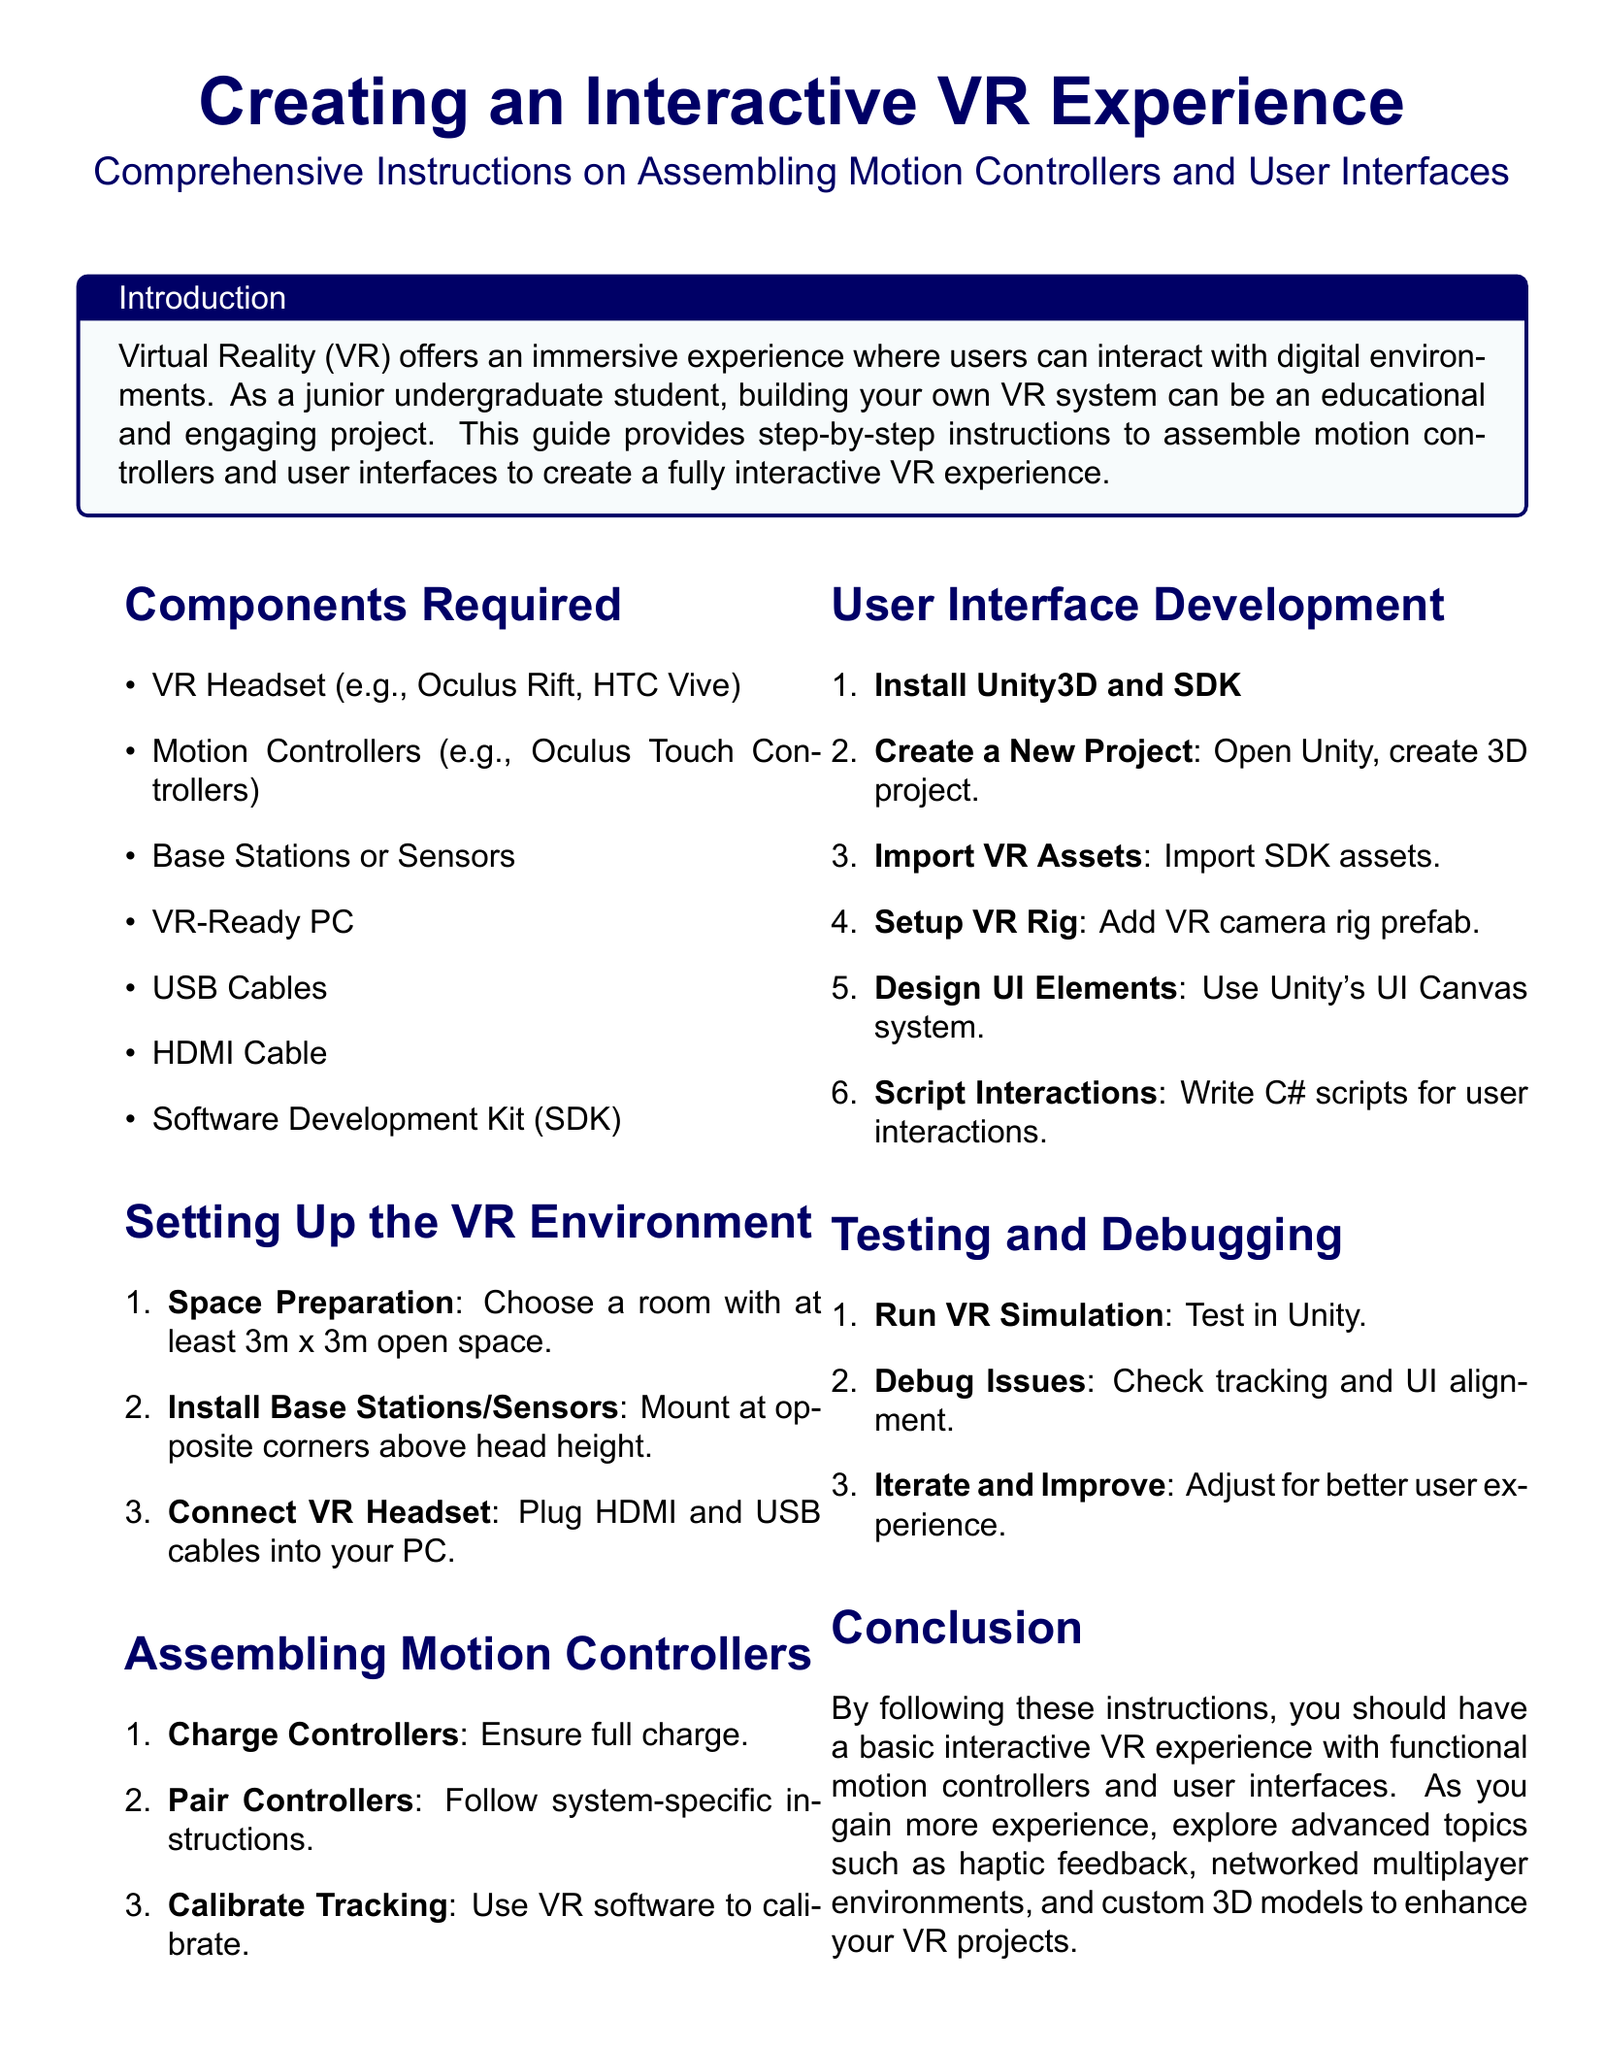What is the VR headset example mentioned? The document lists an example of a VR headset in the "Components Required" section.
Answer: Oculus Rift How many base stations or sensors are required? The instructions imply the use of base stations in the setup; they are mentioned but not quantified in the components required.
Answer: Two Which software is recommended for user interface development? The document specifies a software tool necessary for UI development.
Answer: Unity3D What is the first step in setting up the VR environment? The first step is detailed in the "Setting Up the VR Environment" section.
Answer: Space Preparation What do you do after charging the motion controllers? The next action following charging the controllers is outlined in the "Assembling Motion Controllers" section.
Answer: Pair Controllers What is the purpose of the VR camera rig prefab? The use of the VR camera rig prefab is explained in the context of setting up the VR environment.
Answer: Setup VR Rig What scripting language is used for user interactions? The document specifies the programming language used for scripting interactions.
Answer: C# What should you do if you encounter issues during testing? The debugging process is covered under the "Testing and Debugging" section providing a recommendation if issues arise.
Answer: Debug Issues 